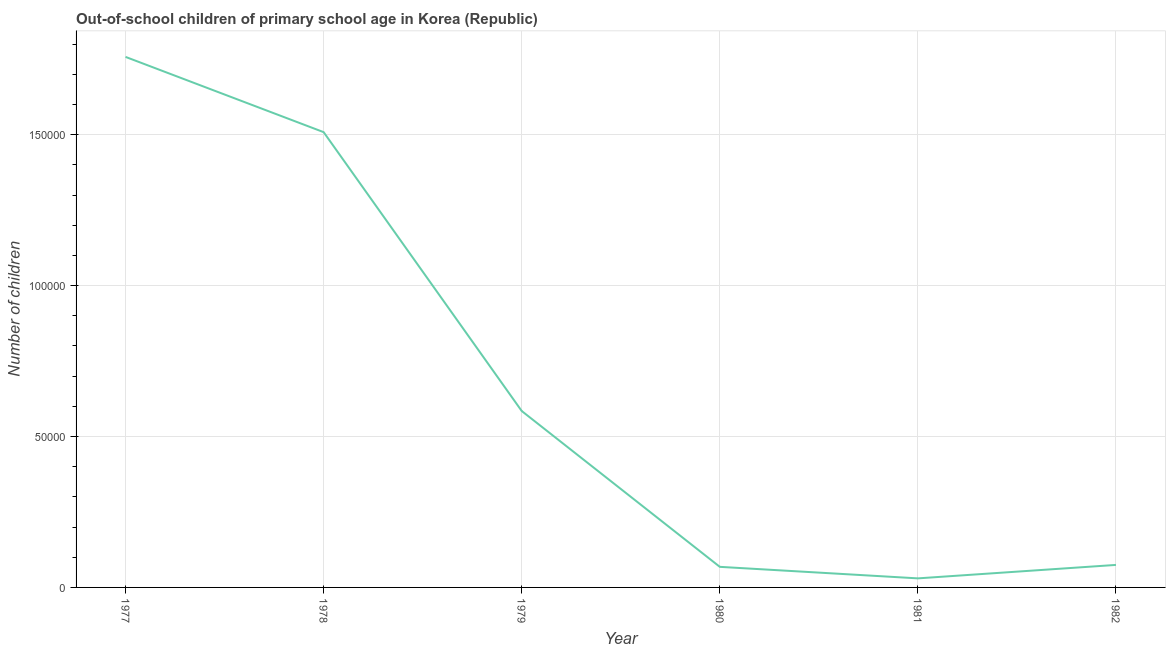What is the number of out-of-school children in 1982?
Keep it short and to the point. 7459. Across all years, what is the maximum number of out-of-school children?
Offer a terse response. 1.76e+05. Across all years, what is the minimum number of out-of-school children?
Your response must be concise. 3001. In which year was the number of out-of-school children maximum?
Give a very brief answer. 1977. What is the sum of the number of out-of-school children?
Ensure brevity in your answer.  4.02e+05. What is the difference between the number of out-of-school children in 1980 and 1981?
Offer a terse response. 3820. What is the average number of out-of-school children per year?
Provide a succinct answer. 6.71e+04. What is the median number of out-of-school children?
Offer a very short reply. 3.30e+04. In how many years, is the number of out-of-school children greater than 160000 ?
Ensure brevity in your answer.  1. Do a majority of the years between 1981 and 1980 (inclusive) have number of out-of-school children greater than 140000 ?
Your answer should be compact. No. What is the ratio of the number of out-of-school children in 1978 to that in 1979?
Provide a succinct answer. 2.58. Is the difference between the number of out-of-school children in 1978 and 1982 greater than the difference between any two years?
Provide a short and direct response. No. What is the difference between the highest and the second highest number of out-of-school children?
Offer a terse response. 2.49e+04. What is the difference between the highest and the lowest number of out-of-school children?
Make the answer very short. 1.73e+05. Are the values on the major ticks of Y-axis written in scientific E-notation?
Ensure brevity in your answer.  No. Does the graph contain any zero values?
Provide a succinct answer. No. What is the title of the graph?
Offer a very short reply. Out-of-school children of primary school age in Korea (Republic). What is the label or title of the X-axis?
Keep it short and to the point. Year. What is the label or title of the Y-axis?
Offer a very short reply. Number of children. What is the Number of children in 1977?
Your answer should be very brief. 1.76e+05. What is the Number of children in 1978?
Provide a succinct answer. 1.51e+05. What is the Number of children in 1979?
Keep it short and to the point. 5.85e+04. What is the Number of children in 1980?
Keep it short and to the point. 6821. What is the Number of children of 1981?
Offer a very short reply. 3001. What is the Number of children in 1982?
Give a very brief answer. 7459. What is the difference between the Number of children in 1977 and 1978?
Your answer should be very brief. 2.49e+04. What is the difference between the Number of children in 1977 and 1979?
Provide a short and direct response. 1.17e+05. What is the difference between the Number of children in 1977 and 1980?
Ensure brevity in your answer.  1.69e+05. What is the difference between the Number of children in 1977 and 1981?
Keep it short and to the point. 1.73e+05. What is the difference between the Number of children in 1977 and 1982?
Keep it short and to the point. 1.68e+05. What is the difference between the Number of children in 1978 and 1979?
Make the answer very short. 9.24e+04. What is the difference between the Number of children in 1978 and 1980?
Offer a very short reply. 1.44e+05. What is the difference between the Number of children in 1978 and 1981?
Make the answer very short. 1.48e+05. What is the difference between the Number of children in 1978 and 1982?
Keep it short and to the point. 1.43e+05. What is the difference between the Number of children in 1979 and 1980?
Your response must be concise. 5.16e+04. What is the difference between the Number of children in 1979 and 1981?
Give a very brief answer. 5.54e+04. What is the difference between the Number of children in 1979 and 1982?
Offer a terse response. 5.10e+04. What is the difference between the Number of children in 1980 and 1981?
Ensure brevity in your answer.  3820. What is the difference between the Number of children in 1980 and 1982?
Make the answer very short. -638. What is the difference between the Number of children in 1981 and 1982?
Offer a very short reply. -4458. What is the ratio of the Number of children in 1977 to that in 1978?
Give a very brief answer. 1.17. What is the ratio of the Number of children in 1977 to that in 1979?
Give a very brief answer. 3.01. What is the ratio of the Number of children in 1977 to that in 1980?
Ensure brevity in your answer.  25.77. What is the ratio of the Number of children in 1977 to that in 1981?
Offer a very short reply. 58.57. What is the ratio of the Number of children in 1977 to that in 1982?
Ensure brevity in your answer.  23.57. What is the ratio of the Number of children in 1978 to that in 1979?
Your answer should be compact. 2.58. What is the ratio of the Number of children in 1978 to that in 1980?
Ensure brevity in your answer.  22.11. What is the ratio of the Number of children in 1978 to that in 1981?
Your answer should be compact. 50.26. What is the ratio of the Number of children in 1978 to that in 1982?
Give a very brief answer. 20.22. What is the ratio of the Number of children in 1979 to that in 1980?
Offer a very short reply. 8.57. What is the ratio of the Number of children in 1979 to that in 1981?
Give a very brief answer. 19.48. What is the ratio of the Number of children in 1979 to that in 1982?
Provide a succinct answer. 7.84. What is the ratio of the Number of children in 1980 to that in 1981?
Offer a terse response. 2.27. What is the ratio of the Number of children in 1980 to that in 1982?
Provide a short and direct response. 0.91. What is the ratio of the Number of children in 1981 to that in 1982?
Your response must be concise. 0.4. 